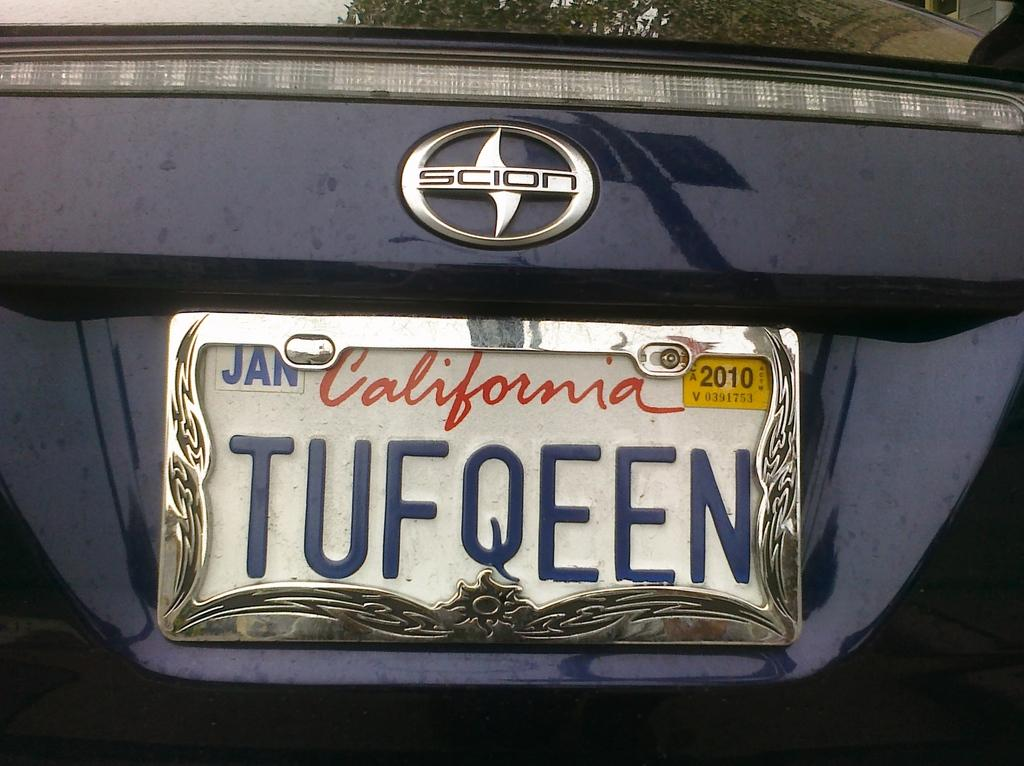<image>
Offer a succinct explanation of the picture presented. A California license plate that reads as tough queen. 